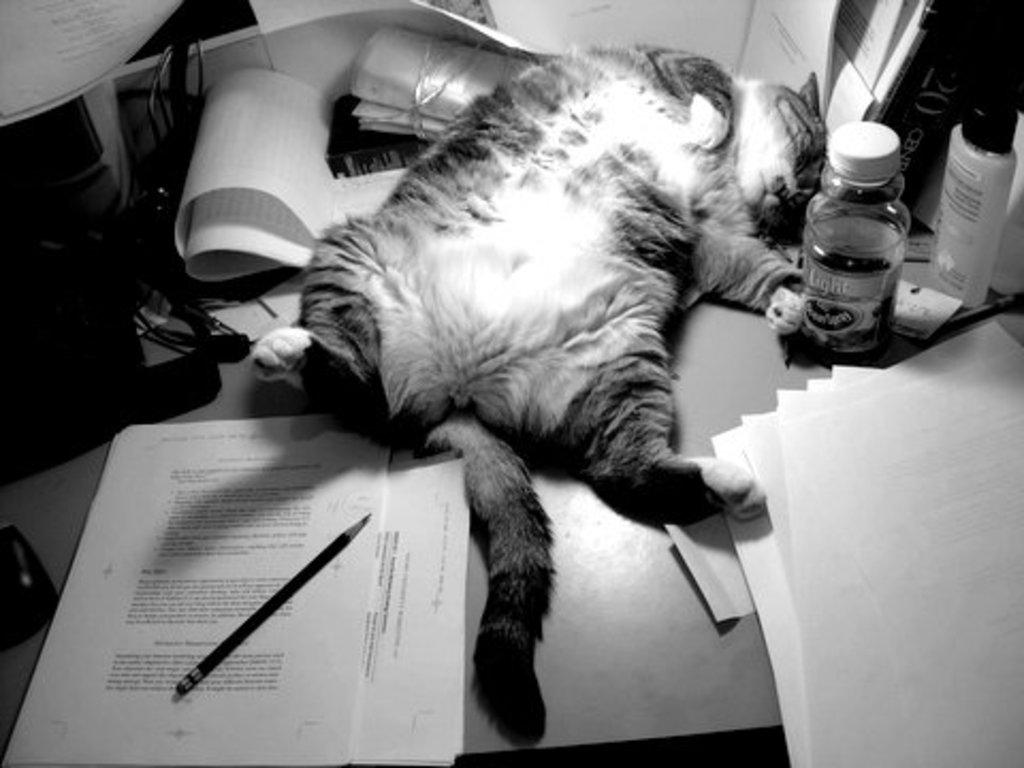What is the color scheme of the image? The image is black and white. What type of animal can be seen in the image? There is a cat in the image. What objects are present in the image besides the cat? There are bottles, papers, a pencil, cables, and a mouse in the image. Where are all the objects located? All objects are on a table. What type of verse can be heard being recited by the cat in the image? There is no verse being recited by the cat in the image, as it is a still image and does not contain any sounds. What question is the mouse asking the cat in the image? There is no interaction between the cat and the mouse in the image, so it is not possible to determine what question the mouse might be asking. 